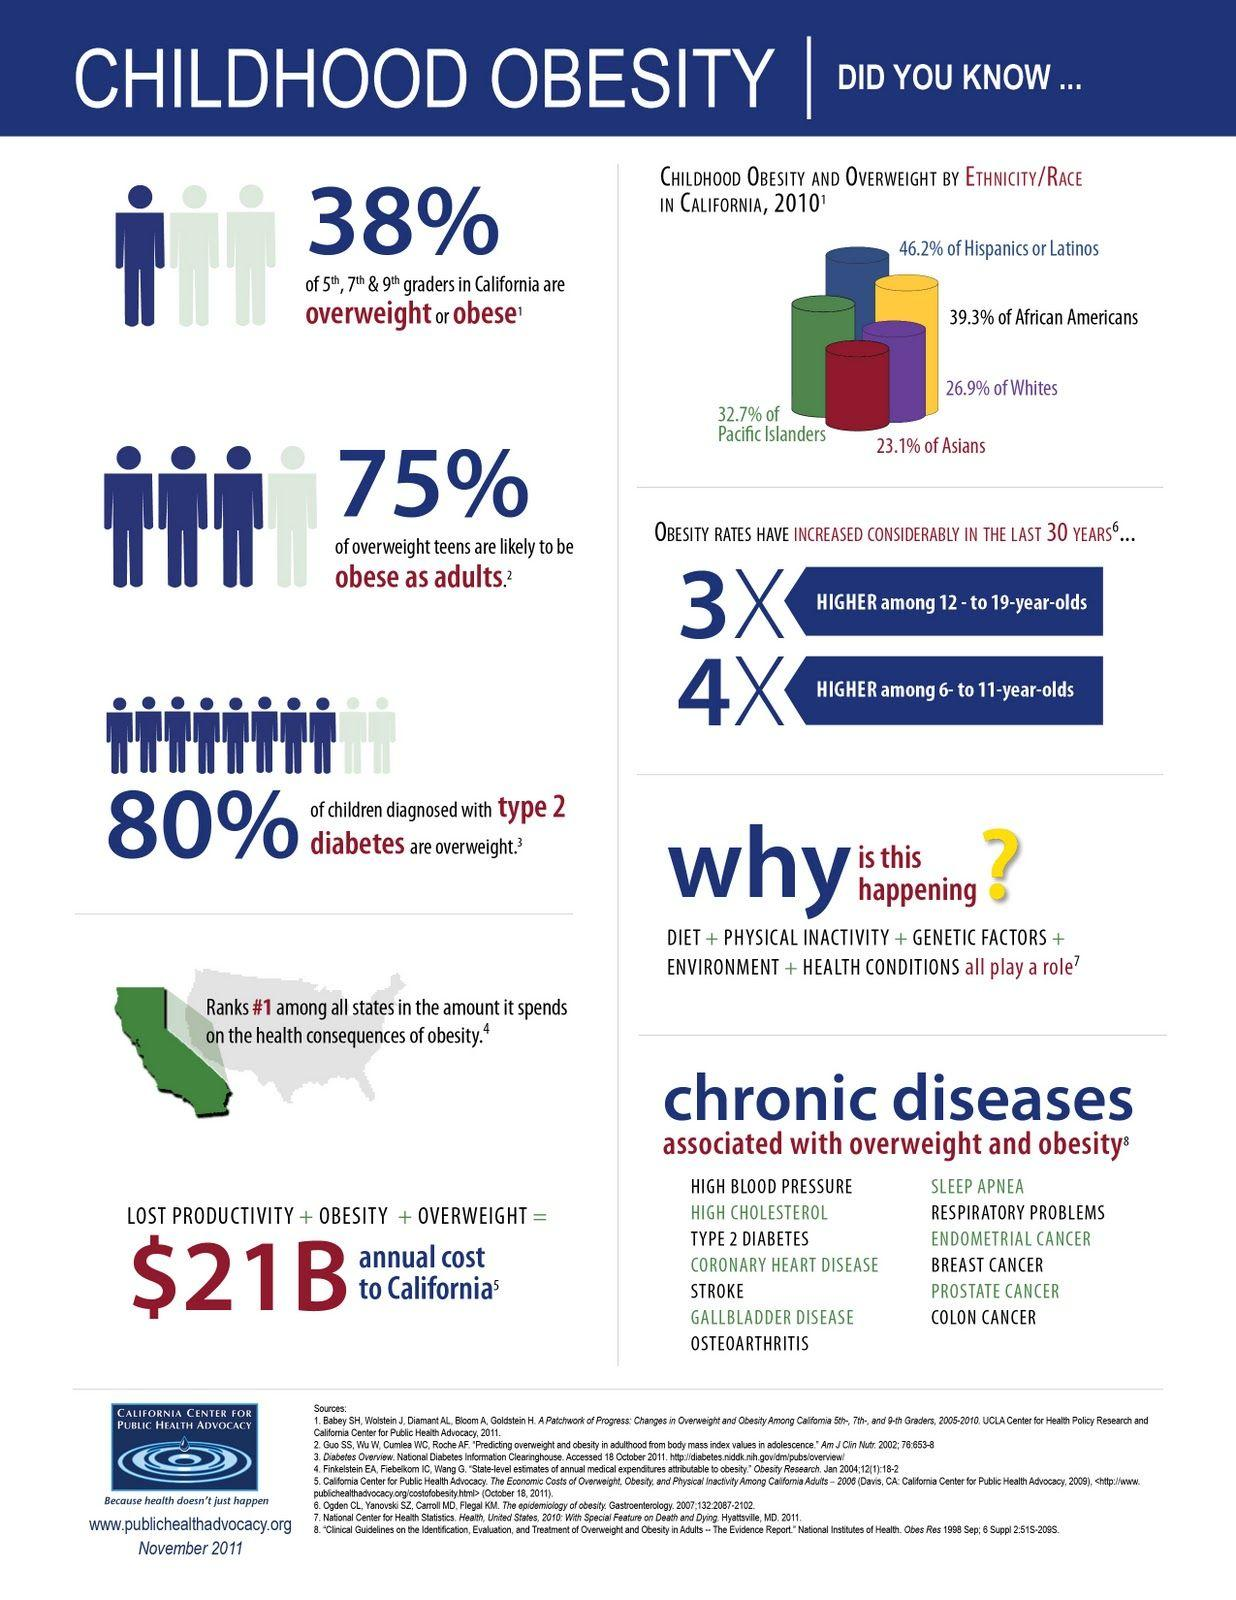Draw attention to some important aspects in this diagram. Overweight and obesity are associated with 13 different diseases. The difference in percentages between Hispanics and African Americans is 6.9%. There are five factors that contribute to childhood obesity. California ranks first in obesity among all states in the United States. According to the data, the ethnicity or race with the second lowest percentage of obesity is white. 